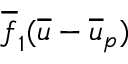<formula> <loc_0><loc_0><loc_500><loc_500>\overline { f } _ { 1 } ( \overline { u } - \overline { u } _ { p } )</formula> 